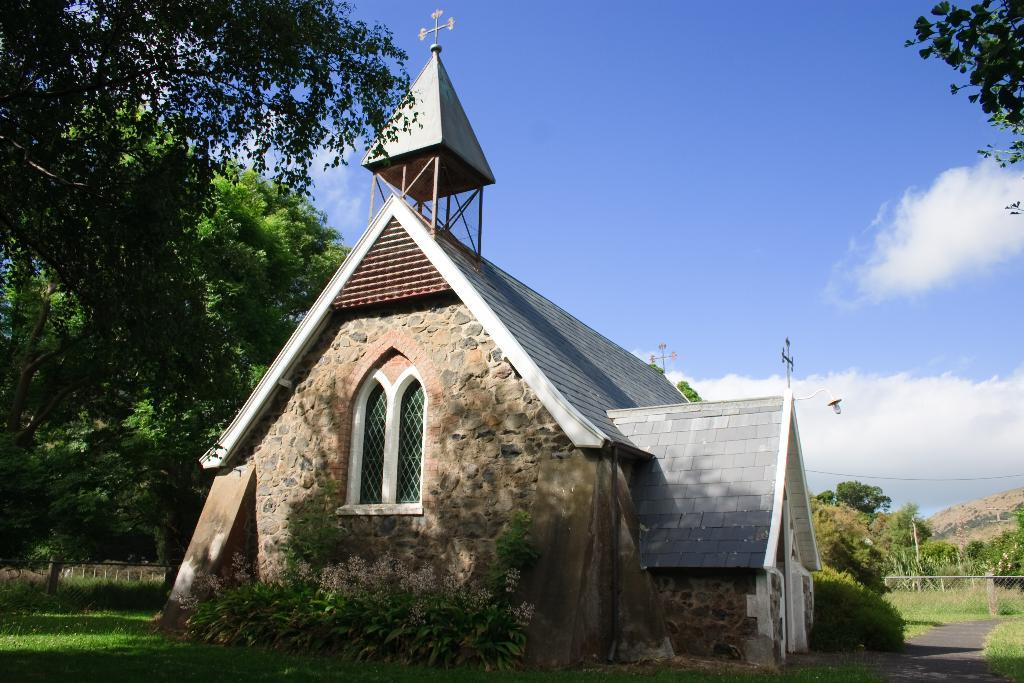What type of structure is visible in the image? There is a building in the image. What type of vegetation can be seen in the image? There are trees and plants in the image. What is on the ground in the image? There is grass on the ground in the image. What can be seen in the sky in the image? The sky is blue and cloudy in the image. What source of illumination is present in the image? There is a light in the image. What type of lunch is being served in the image? There is no lunch present in the image; it features a building, trees, plants, grass, a light, and a blue and cloudy sky. What type of crime is being committed in the image? There is no crime present in the image; it features a building, trees, plants, grass, a light, and a blue and cloudy sky. 